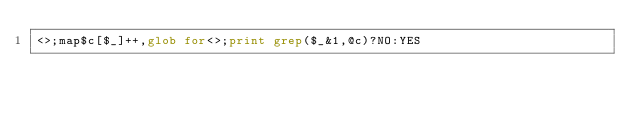<code> <loc_0><loc_0><loc_500><loc_500><_Perl_><>;map$c[$_]++,glob for<>;print grep($_&1,@c)?NO:YES</code> 